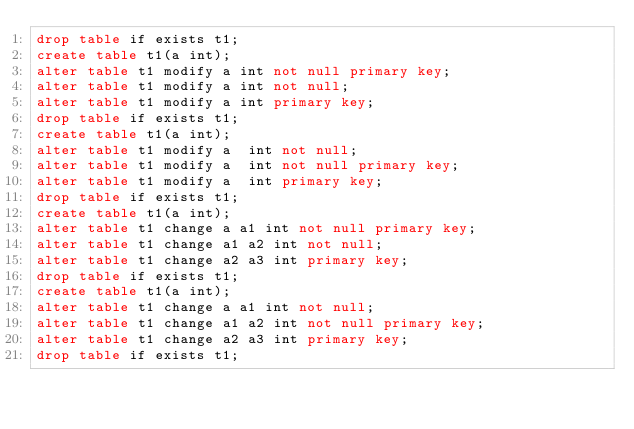Convert code to text. <code><loc_0><loc_0><loc_500><loc_500><_SQL_>drop table if exists t1;
create table t1(a int);
alter table t1 modify a int not null primary key;
alter table t1 modify a int not null;
alter table t1 modify a int primary key;
drop table if exists t1;
create table t1(a int);
alter table t1 modify a  int not null;
alter table t1 modify a  int not null primary key;
alter table t1 modify a  int primary key;
drop table if exists t1;
create table t1(a int);
alter table t1 change a a1 int not null primary key;
alter table t1 change a1 a2 int not null;
alter table t1 change a2 a3 int primary key;
drop table if exists t1;
create table t1(a int);
alter table t1 change a a1 int not null;
alter table t1 change a1 a2 int not null primary key;
alter table t1 change a2 a3 int primary key;
drop table if exists t1;
</code> 